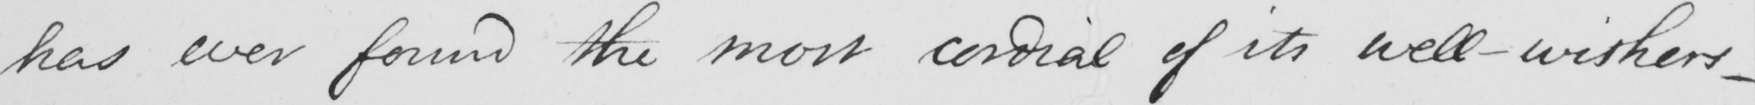What does this handwritten line say? has ever found the most cordial of its well-wishers  _ 